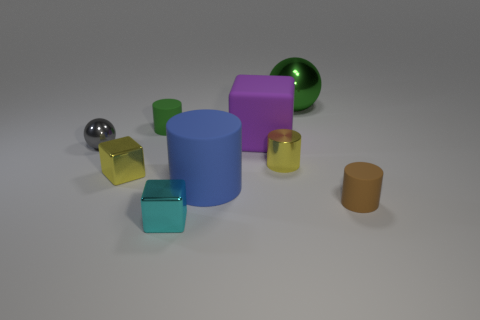Are there more small blue balls than yellow shiny cylinders?
Give a very brief answer. No. What number of green metal cylinders are there?
Provide a short and direct response. 0. There is a small cyan metal thing in front of the yellow thing on the left side of the small matte thing that is on the left side of the large matte cylinder; what is its shape?
Offer a terse response. Cube. Is the number of big purple matte blocks that are in front of the large blue cylinder less than the number of gray metal balls behind the tiny shiny sphere?
Give a very brief answer. No. There is a tiny yellow metal object that is left of the blue matte thing; is its shape the same as the tiny green object behind the small brown cylinder?
Give a very brief answer. No. There is a small yellow shiny object in front of the small yellow metal thing that is on the right side of the small cyan metal object; what is its shape?
Offer a terse response. Cube. There is a metallic block that is the same color as the metal cylinder; what size is it?
Offer a very short reply. Small. Is there a tiny yellow cylinder that has the same material as the tiny gray object?
Offer a terse response. Yes. There is a big object that is in front of the yellow cylinder; what material is it?
Offer a very short reply. Rubber. What is the small yellow cube made of?
Offer a very short reply. Metal. 